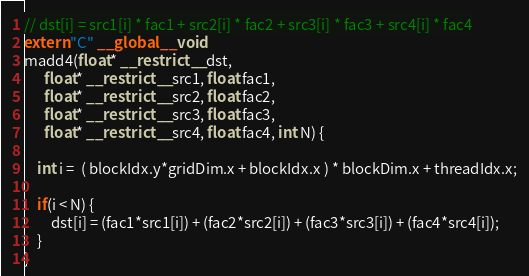Convert code to text. <code><loc_0><loc_0><loc_500><loc_500><_Cuda_>
// dst[i] = src1[i] * fac1 + src2[i] * fac2 + src3[i] * fac3 + src4[i] * fac4
extern "C" __global__ void
madd4(float* __restrict__ dst,
      float* __restrict__ src1, float fac1,
      float* __restrict__ src2, float fac2,
      float* __restrict__ src3, float fac3,
      float* __restrict__ src4, float fac4, int N) {

    int i =  ( blockIdx.y*gridDim.x + blockIdx.x ) * blockDim.x + threadIdx.x;

    if(i < N) {
        dst[i] = (fac1*src1[i]) + (fac2*src2[i]) + (fac3*src3[i]) + (fac4*src4[i]);
    }
}

</code> 